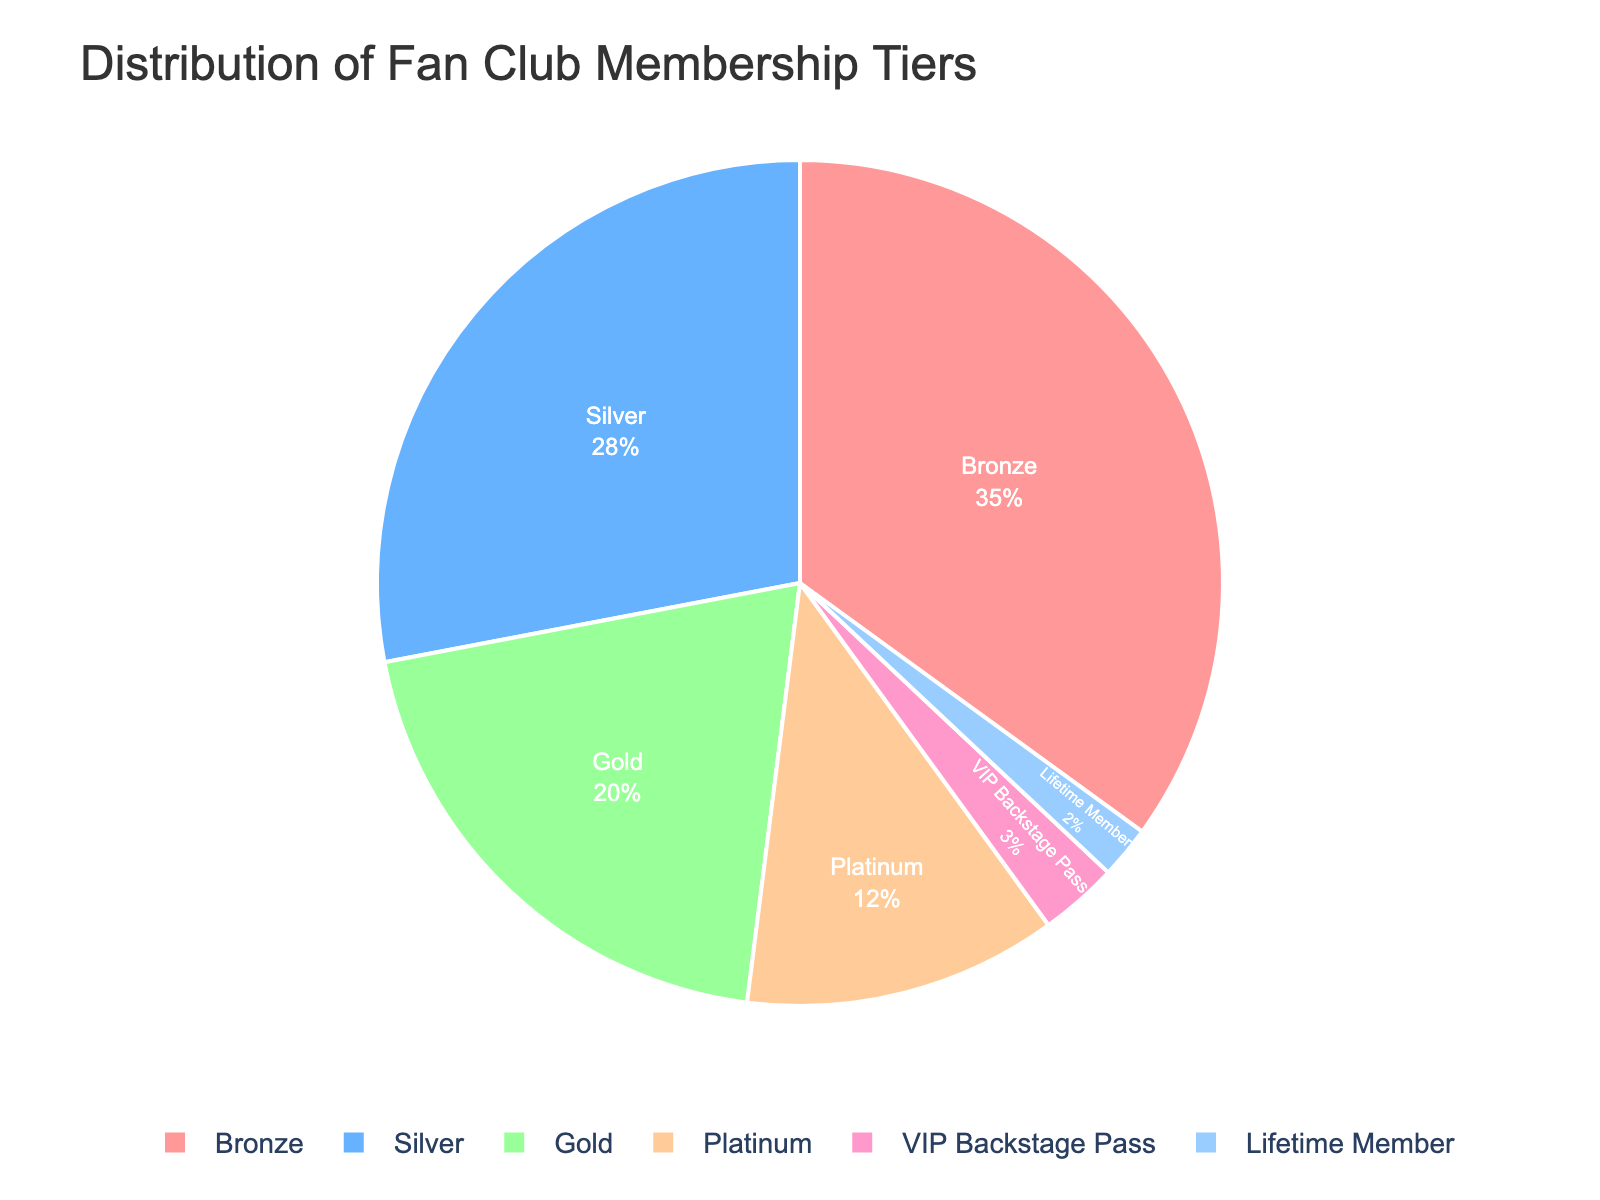What's the largest membership tier by percentage? The figure shows various membership tiers with their respective percentages. By comparing these percentages, we see that Bronze has the highest at 35%.
Answer: Bronze Which membership tier has the smallest percentage? The chart indicates the different tiers with their percentages. The smallest percentage is found in the Lifetime Member tier at 2%.
Answer: Lifetime Member What is the combined percentage of Bronze and Silver membership tiers? To find the combined percentage, add the percentages of Bronze (35%) and Silver (28%). This gives 35 + 28 = 63%.
Answer: 63% Is the Platinum tier percentage greater or less than the Gold tier? The figure shows that Platinum has a 12% share and Gold has a 20% share. Since 12% is less than 20%, Platinum is less than Gold.
Answer: Less What percentage of the fan club membership tiers are either Platinum or VIP Backstage Pass? Add the percentages of Platinum (12%) and VIP Backstage Pass (3%). The total is 12 + 3 = 15%.
Answer: 15% Which membership tier is represented by a greenish segment? By observing the colors in the pie chart, the greenish segment corresponds to the Gold membership tier.
Answer: Gold How much more percentage does the Silver tier have compared to the VIP Backstage Pass tier? Subtract the VIP Backstage Pass percentage (3%) from the Silver percentage (28%). This results in 28 - 3 = 25%.
Answer: 25% What's the difference between the highest and lowest membership tier percentages? Bronze is the highest at 35% and Lifetime Member is the lowest at 2%. The difference is 35 - 2 = 33%.
Answer: 33% Which tiers combined make up half of the total membership? The combined percentage of Bronze (35%) and Silver (28%) exceeds half the total (63%). However, the combined percentage of Gold (20%), Platinum (12%), VIP Backstage Pass (3%), and Lifetime Member (2%) is less. Finally, Bronze is 35% and Silver is 28%. Their combined percentage is closest.
Answer: Bronze and Silver 